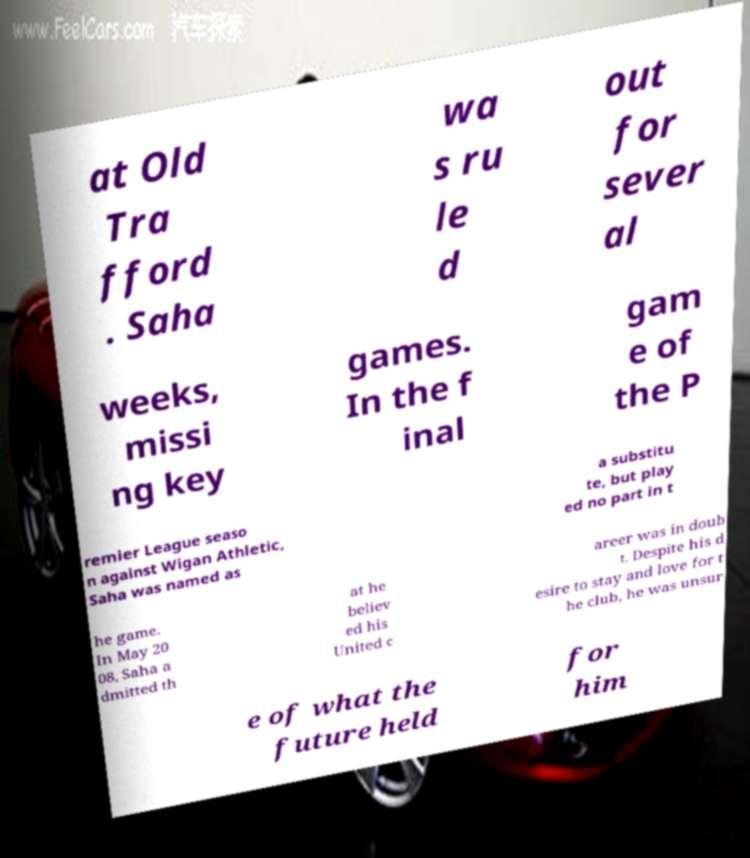Could you extract and type out the text from this image? at Old Tra fford . Saha wa s ru le d out for sever al weeks, missi ng key games. In the f inal gam e of the P remier League seaso n against Wigan Athletic, Saha was named as a substitu te, but play ed no part in t he game. In May 20 08, Saha a dmitted th at he believ ed his United c areer was in doub t. Despite his d esire to stay and love for t he club, he was unsur e of what the future held for him 